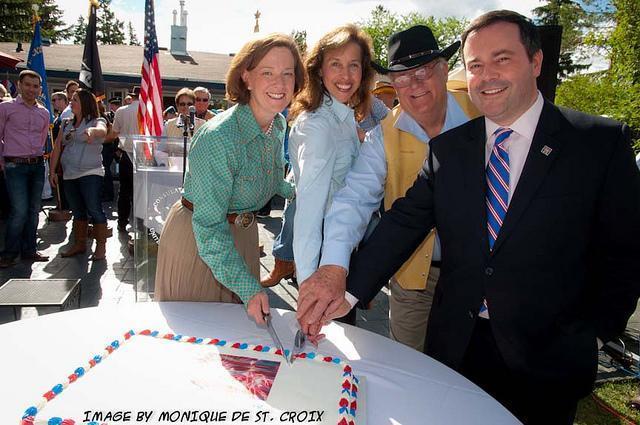How many people look like they're cutting the cake?
Give a very brief answer. 4. How many people are there?
Give a very brief answer. 8. How many dining tables are in the photo?
Give a very brief answer. 2. 